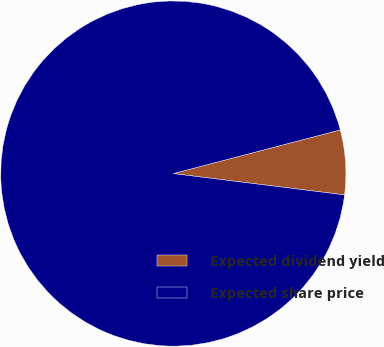Convert chart to OTSL. <chart><loc_0><loc_0><loc_500><loc_500><pie_chart><fcel>Expected dividend yield<fcel>Expected share price<nl><fcel>6.04%<fcel>93.96%<nl></chart> 